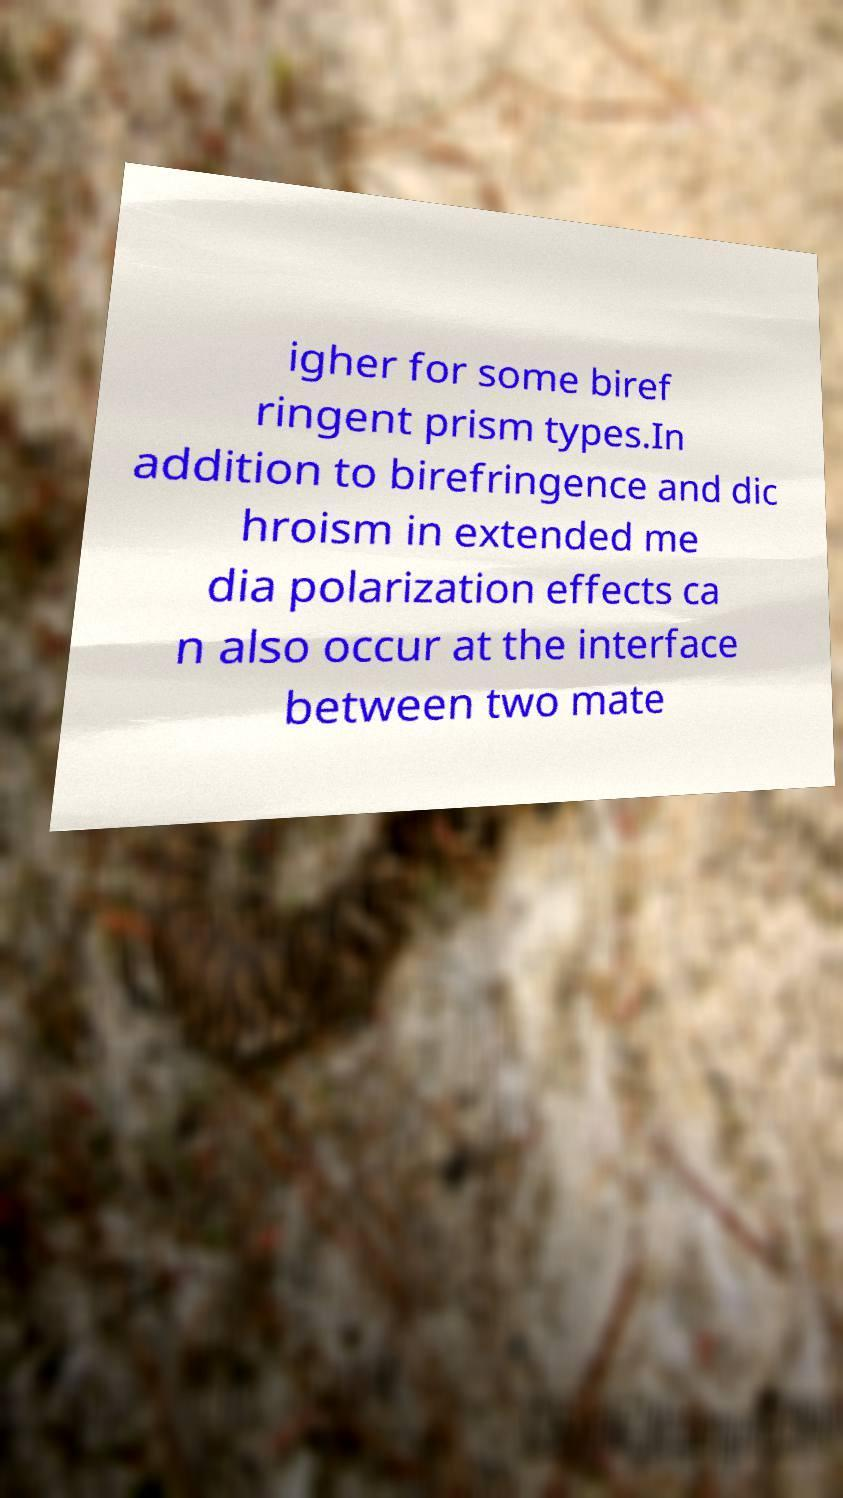Please read and relay the text visible in this image. What does it say? igher for some biref ringent prism types.In addition to birefringence and dic hroism in extended me dia polarization effects ca n also occur at the interface between two mate 